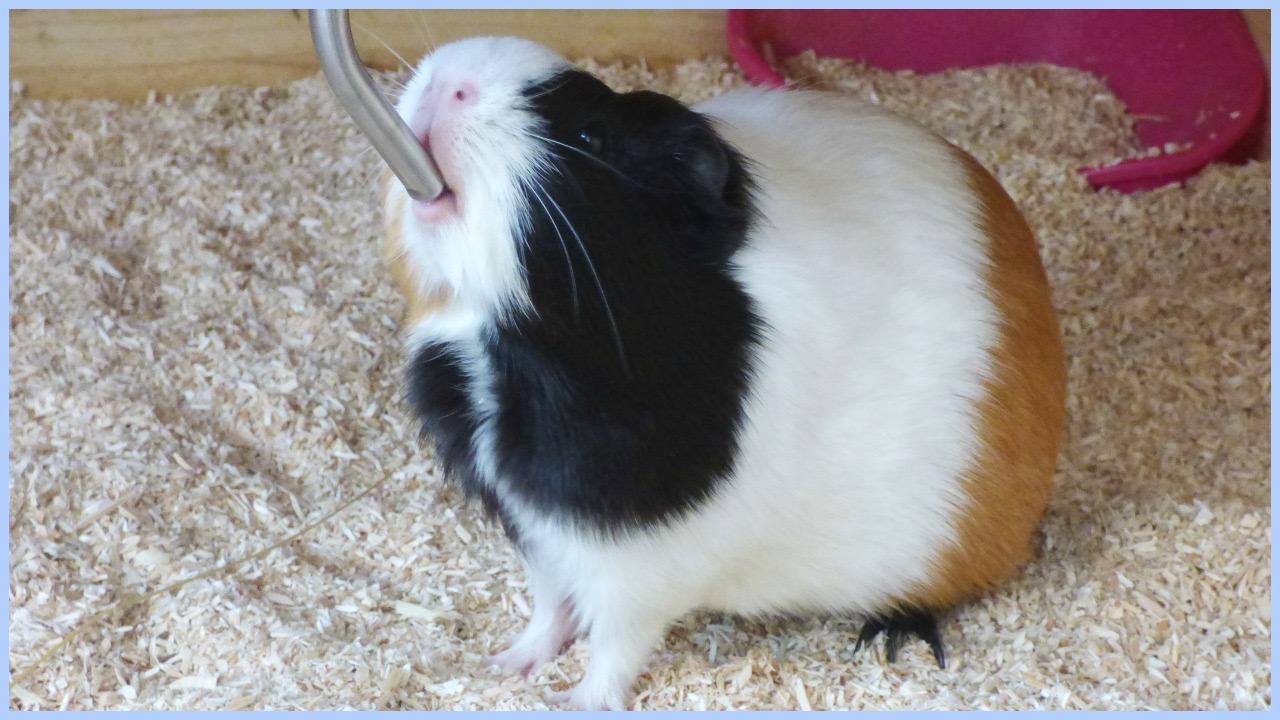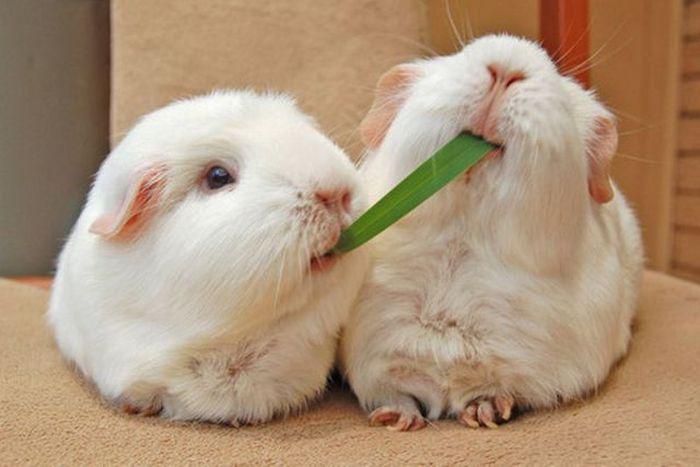The first image is the image on the left, the second image is the image on the right. For the images displayed, is the sentence "In one image, two guinea pigs have on green food item in both their mouths" factually correct? Answer yes or no. Yes. The first image is the image on the left, the second image is the image on the right. Assess this claim about the two images: "There is no more than one rodent in the left image.". Correct or not? Answer yes or no. Yes. 